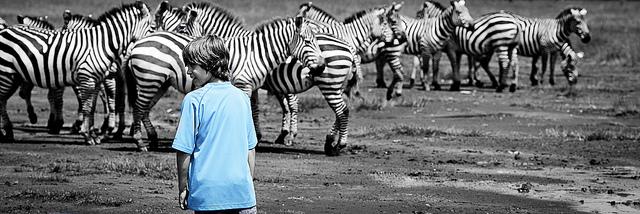Is the person in blue a man or a woman?
Keep it brief. Man. Is the ground muddy?
Give a very brief answer. Yes. What animals are in the back?
Give a very brief answer. Zebras. 